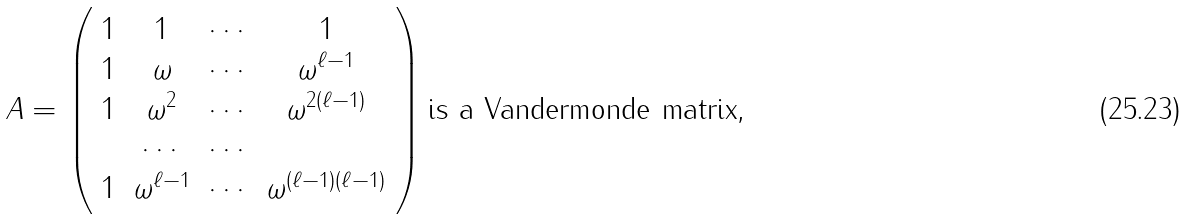<formula> <loc_0><loc_0><loc_500><loc_500>A = \left ( \begin{array} { c c c c } 1 & 1 & \cdots & 1 \\ 1 & \omega & \cdots & \omega ^ { \ell - 1 } \\ 1 & \omega ^ { 2 } & \cdots & \omega ^ { 2 ( \ell - 1 ) } \\ & \cdots & \cdots & \\ 1 & \omega ^ { \ell - 1 } & \cdots & \omega ^ { ( \ell - 1 ) ( \ell - 1 ) } \end{array} \right ) \text {is a Vandermonde matrix,}</formula> 